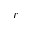<formula> <loc_0><loc_0><loc_500><loc_500>r</formula> 